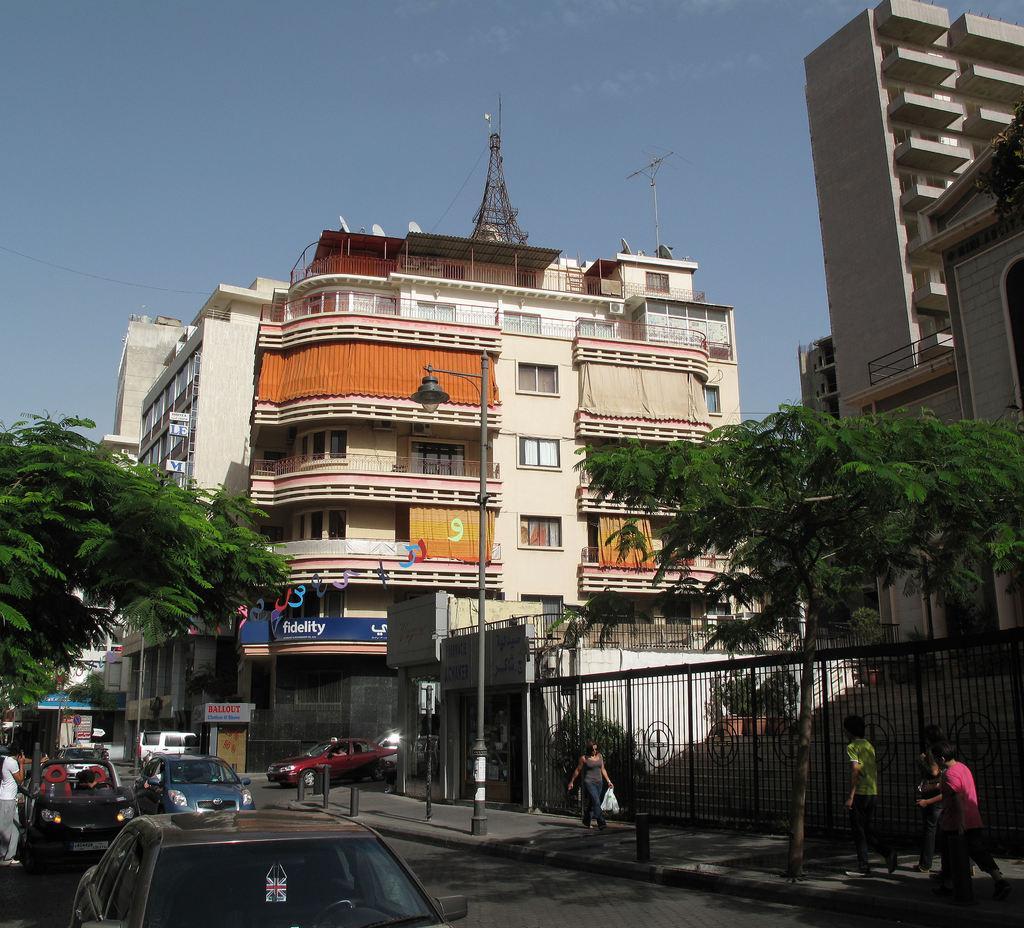How would you summarize this image in a sentence or two? In this image I can see few vehicles on the road and a person wearing white shirt and grey pant is standing on the road and I can see few persons walking on the side walk, a black colored pole on the sidewalk, the railing, few trees and few buildings. In the background I can see a tower and the sky. 